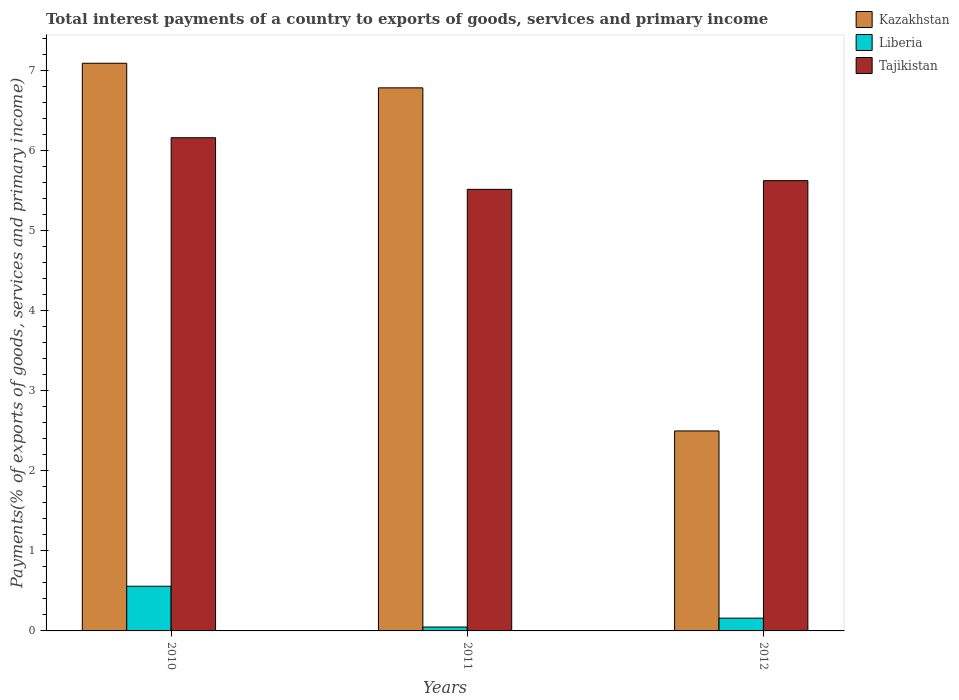How many different coloured bars are there?
Your answer should be very brief. 3. Are the number of bars per tick equal to the number of legend labels?
Offer a terse response. Yes. How many bars are there on the 3rd tick from the left?
Make the answer very short. 3. What is the label of the 3rd group of bars from the left?
Your response must be concise. 2012. What is the total interest payments in Kazakhstan in 2011?
Ensure brevity in your answer.  6.78. Across all years, what is the maximum total interest payments in Tajikistan?
Provide a succinct answer. 6.16. Across all years, what is the minimum total interest payments in Liberia?
Your response must be concise. 0.05. What is the total total interest payments in Liberia in the graph?
Keep it short and to the point. 0.77. What is the difference between the total interest payments in Kazakhstan in 2011 and that in 2012?
Keep it short and to the point. 4.28. What is the difference between the total interest payments in Liberia in 2011 and the total interest payments in Kazakhstan in 2010?
Provide a short and direct response. -7.04. What is the average total interest payments in Tajikistan per year?
Keep it short and to the point. 5.76. In the year 2012, what is the difference between the total interest payments in Liberia and total interest payments in Kazakhstan?
Make the answer very short. -2.34. In how many years, is the total interest payments in Liberia greater than 2.8 %?
Provide a succinct answer. 0. What is the ratio of the total interest payments in Liberia in 2011 to that in 2012?
Keep it short and to the point. 0.3. Is the difference between the total interest payments in Liberia in 2010 and 2011 greater than the difference between the total interest payments in Kazakhstan in 2010 and 2011?
Your answer should be compact. Yes. What is the difference between the highest and the second highest total interest payments in Liberia?
Provide a short and direct response. 0.4. What is the difference between the highest and the lowest total interest payments in Liberia?
Your response must be concise. 0.51. Is the sum of the total interest payments in Kazakhstan in 2011 and 2012 greater than the maximum total interest payments in Liberia across all years?
Offer a very short reply. Yes. What does the 2nd bar from the left in 2012 represents?
Provide a short and direct response. Liberia. What does the 3rd bar from the right in 2010 represents?
Ensure brevity in your answer.  Kazakhstan. How many bars are there?
Keep it short and to the point. 9. How many years are there in the graph?
Offer a very short reply. 3. Where does the legend appear in the graph?
Give a very brief answer. Top right. What is the title of the graph?
Make the answer very short. Total interest payments of a country to exports of goods, services and primary income. What is the label or title of the Y-axis?
Provide a short and direct response. Payments(% of exports of goods, services and primary income). What is the Payments(% of exports of goods, services and primary income) in Kazakhstan in 2010?
Your answer should be compact. 7.09. What is the Payments(% of exports of goods, services and primary income) of Liberia in 2010?
Your answer should be compact. 0.56. What is the Payments(% of exports of goods, services and primary income) in Tajikistan in 2010?
Offer a very short reply. 6.16. What is the Payments(% of exports of goods, services and primary income) of Kazakhstan in 2011?
Make the answer very short. 6.78. What is the Payments(% of exports of goods, services and primary income) of Liberia in 2011?
Your response must be concise. 0.05. What is the Payments(% of exports of goods, services and primary income) of Tajikistan in 2011?
Your response must be concise. 5.51. What is the Payments(% of exports of goods, services and primary income) of Kazakhstan in 2012?
Your answer should be very brief. 2.5. What is the Payments(% of exports of goods, services and primary income) in Liberia in 2012?
Make the answer very short. 0.16. What is the Payments(% of exports of goods, services and primary income) in Tajikistan in 2012?
Keep it short and to the point. 5.62. Across all years, what is the maximum Payments(% of exports of goods, services and primary income) in Kazakhstan?
Provide a succinct answer. 7.09. Across all years, what is the maximum Payments(% of exports of goods, services and primary income) in Liberia?
Your answer should be very brief. 0.56. Across all years, what is the maximum Payments(% of exports of goods, services and primary income) in Tajikistan?
Your answer should be very brief. 6.16. Across all years, what is the minimum Payments(% of exports of goods, services and primary income) in Kazakhstan?
Offer a terse response. 2.5. Across all years, what is the minimum Payments(% of exports of goods, services and primary income) in Liberia?
Offer a very short reply. 0.05. Across all years, what is the minimum Payments(% of exports of goods, services and primary income) in Tajikistan?
Ensure brevity in your answer.  5.51. What is the total Payments(% of exports of goods, services and primary income) in Kazakhstan in the graph?
Provide a succinct answer. 16.37. What is the total Payments(% of exports of goods, services and primary income) of Liberia in the graph?
Your response must be concise. 0.77. What is the total Payments(% of exports of goods, services and primary income) in Tajikistan in the graph?
Offer a very short reply. 17.29. What is the difference between the Payments(% of exports of goods, services and primary income) of Kazakhstan in 2010 and that in 2011?
Your response must be concise. 0.31. What is the difference between the Payments(% of exports of goods, services and primary income) in Liberia in 2010 and that in 2011?
Ensure brevity in your answer.  0.51. What is the difference between the Payments(% of exports of goods, services and primary income) in Tajikistan in 2010 and that in 2011?
Provide a succinct answer. 0.64. What is the difference between the Payments(% of exports of goods, services and primary income) in Kazakhstan in 2010 and that in 2012?
Keep it short and to the point. 4.59. What is the difference between the Payments(% of exports of goods, services and primary income) in Liberia in 2010 and that in 2012?
Offer a terse response. 0.4. What is the difference between the Payments(% of exports of goods, services and primary income) of Tajikistan in 2010 and that in 2012?
Your response must be concise. 0.54. What is the difference between the Payments(% of exports of goods, services and primary income) in Kazakhstan in 2011 and that in 2012?
Your answer should be very brief. 4.28. What is the difference between the Payments(% of exports of goods, services and primary income) of Liberia in 2011 and that in 2012?
Your response must be concise. -0.11. What is the difference between the Payments(% of exports of goods, services and primary income) of Tajikistan in 2011 and that in 2012?
Provide a short and direct response. -0.11. What is the difference between the Payments(% of exports of goods, services and primary income) in Kazakhstan in 2010 and the Payments(% of exports of goods, services and primary income) in Liberia in 2011?
Provide a short and direct response. 7.04. What is the difference between the Payments(% of exports of goods, services and primary income) of Kazakhstan in 2010 and the Payments(% of exports of goods, services and primary income) of Tajikistan in 2011?
Keep it short and to the point. 1.57. What is the difference between the Payments(% of exports of goods, services and primary income) in Liberia in 2010 and the Payments(% of exports of goods, services and primary income) in Tajikistan in 2011?
Your answer should be very brief. -4.96. What is the difference between the Payments(% of exports of goods, services and primary income) of Kazakhstan in 2010 and the Payments(% of exports of goods, services and primary income) of Liberia in 2012?
Give a very brief answer. 6.93. What is the difference between the Payments(% of exports of goods, services and primary income) of Kazakhstan in 2010 and the Payments(% of exports of goods, services and primary income) of Tajikistan in 2012?
Make the answer very short. 1.47. What is the difference between the Payments(% of exports of goods, services and primary income) of Liberia in 2010 and the Payments(% of exports of goods, services and primary income) of Tajikistan in 2012?
Your answer should be very brief. -5.06. What is the difference between the Payments(% of exports of goods, services and primary income) in Kazakhstan in 2011 and the Payments(% of exports of goods, services and primary income) in Liberia in 2012?
Provide a short and direct response. 6.62. What is the difference between the Payments(% of exports of goods, services and primary income) of Kazakhstan in 2011 and the Payments(% of exports of goods, services and primary income) of Tajikistan in 2012?
Offer a very short reply. 1.16. What is the difference between the Payments(% of exports of goods, services and primary income) of Liberia in 2011 and the Payments(% of exports of goods, services and primary income) of Tajikistan in 2012?
Give a very brief answer. -5.57. What is the average Payments(% of exports of goods, services and primary income) in Kazakhstan per year?
Your response must be concise. 5.46. What is the average Payments(% of exports of goods, services and primary income) of Liberia per year?
Your answer should be very brief. 0.26. What is the average Payments(% of exports of goods, services and primary income) of Tajikistan per year?
Your response must be concise. 5.76. In the year 2010, what is the difference between the Payments(% of exports of goods, services and primary income) of Kazakhstan and Payments(% of exports of goods, services and primary income) of Liberia?
Give a very brief answer. 6.53. In the year 2010, what is the difference between the Payments(% of exports of goods, services and primary income) of Kazakhstan and Payments(% of exports of goods, services and primary income) of Tajikistan?
Provide a short and direct response. 0.93. In the year 2010, what is the difference between the Payments(% of exports of goods, services and primary income) in Liberia and Payments(% of exports of goods, services and primary income) in Tajikistan?
Your answer should be very brief. -5.6. In the year 2011, what is the difference between the Payments(% of exports of goods, services and primary income) of Kazakhstan and Payments(% of exports of goods, services and primary income) of Liberia?
Offer a terse response. 6.73. In the year 2011, what is the difference between the Payments(% of exports of goods, services and primary income) in Kazakhstan and Payments(% of exports of goods, services and primary income) in Tajikistan?
Provide a succinct answer. 1.27. In the year 2011, what is the difference between the Payments(% of exports of goods, services and primary income) in Liberia and Payments(% of exports of goods, services and primary income) in Tajikistan?
Offer a very short reply. -5.47. In the year 2012, what is the difference between the Payments(% of exports of goods, services and primary income) in Kazakhstan and Payments(% of exports of goods, services and primary income) in Liberia?
Your answer should be compact. 2.34. In the year 2012, what is the difference between the Payments(% of exports of goods, services and primary income) of Kazakhstan and Payments(% of exports of goods, services and primary income) of Tajikistan?
Make the answer very short. -3.13. In the year 2012, what is the difference between the Payments(% of exports of goods, services and primary income) of Liberia and Payments(% of exports of goods, services and primary income) of Tajikistan?
Keep it short and to the point. -5.46. What is the ratio of the Payments(% of exports of goods, services and primary income) of Kazakhstan in 2010 to that in 2011?
Offer a terse response. 1.05. What is the ratio of the Payments(% of exports of goods, services and primary income) of Liberia in 2010 to that in 2011?
Make the answer very short. 11.49. What is the ratio of the Payments(% of exports of goods, services and primary income) in Tajikistan in 2010 to that in 2011?
Your answer should be compact. 1.12. What is the ratio of the Payments(% of exports of goods, services and primary income) in Kazakhstan in 2010 to that in 2012?
Offer a terse response. 2.84. What is the ratio of the Payments(% of exports of goods, services and primary income) of Liberia in 2010 to that in 2012?
Give a very brief answer. 3.5. What is the ratio of the Payments(% of exports of goods, services and primary income) of Tajikistan in 2010 to that in 2012?
Keep it short and to the point. 1.1. What is the ratio of the Payments(% of exports of goods, services and primary income) of Kazakhstan in 2011 to that in 2012?
Provide a succinct answer. 2.72. What is the ratio of the Payments(% of exports of goods, services and primary income) of Liberia in 2011 to that in 2012?
Give a very brief answer. 0.3. What is the ratio of the Payments(% of exports of goods, services and primary income) of Tajikistan in 2011 to that in 2012?
Ensure brevity in your answer.  0.98. What is the difference between the highest and the second highest Payments(% of exports of goods, services and primary income) of Kazakhstan?
Keep it short and to the point. 0.31. What is the difference between the highest and the second highest Payments(% of exports of goods, services and primary income) in Liberia?
Make the answer very short. 0.4. What is the difference between the highest and the second highest Payments(% of exports of goods, services and primary income) in Tajikistan?
Your answer should be compact. 0.54. What is the difference between the highest and the lowest Payments(% of exports of goods, services and primary income) in Kazakhstan?
Provide a succinct answer. 4.59. What is the difference between the highest and the lowest Payments(% of exports of goods, services and primary income) in Liberia?
Provide a short and direct response. 0.51. What is the difference between the highest and the lowest Payments(% of exports of goods, services and primary income) of Tajikistan?
Provide a succinct answer. 0.64. 